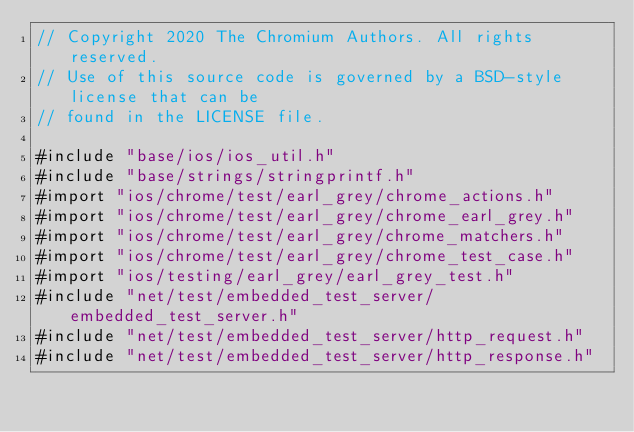<code> <loc_0><loc_0><loc_500><loc_500><_ObjectiveC_>// Copyright 2020 The Chromium Authors. All rights reserved.
// Use of this source code is governed by a BSD-style license that can be
// found in the LICENSE file.

#include "base/ios/ios_util.h"
#include "base/strings/stringprintf.h"
#import "ios/chrome/test/earl_grey/chrome_actions.h"
#import "ios/chrome/test/earl_grey/chrome_earl_grey.h"
#import "ios/chrome/test/earl_grey/chrome_matchers.h"
#import "ios/chrome/test/earl_grey/chrome_test_case.h"
#import "ios/testing/earl_grey/earl_grey_test.h"
#include "net/test/embedded_test_server/embedded_test_server.h"
#include "net/test/embedded_test_server/http_request.h"
#include "net/test/embedded_test_server/http_response.h"
</code> 